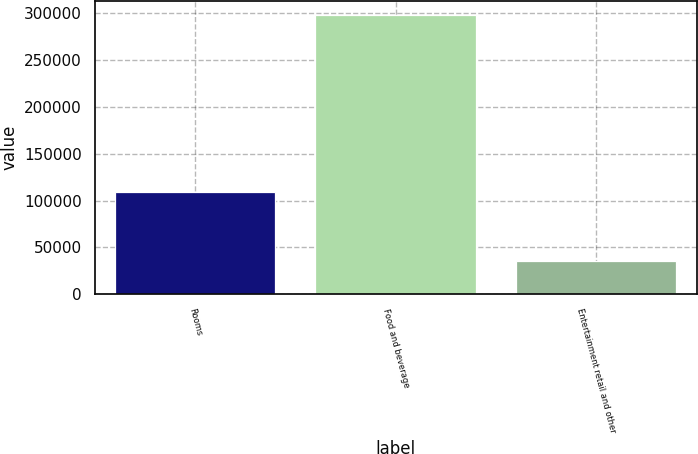Convert chart. <chart><loc_0><loc_0><loc_500><loc_500><bar_chart><fcel>Rooms<fcel>Food and beverage<fcel>Entertainment retail and other<nl><fcel>109713<fcel>298111<fcel>35643<nl></chart> 